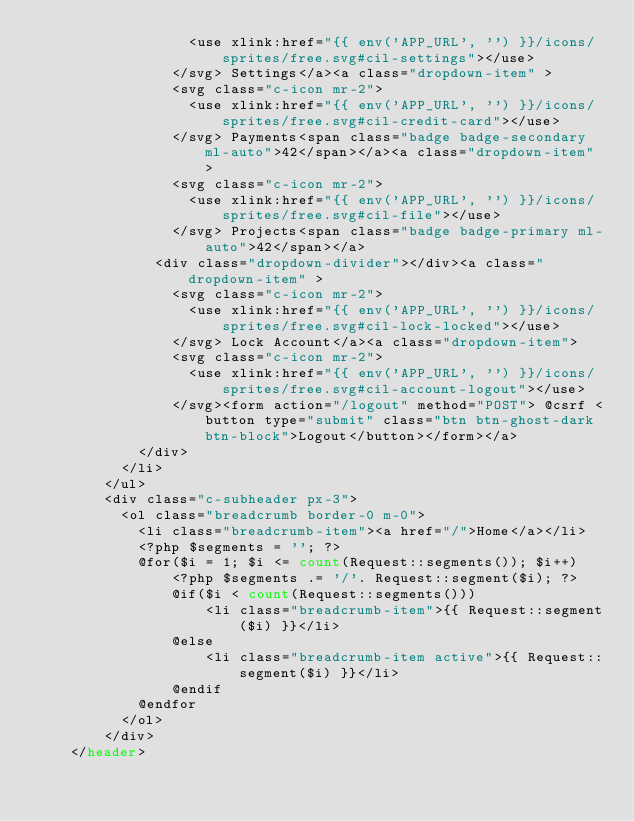Convert code to text. <code><loc_0><loc_0><loc_500><loc_500><_PHP_>                  <use xlink:href="{{ env('APP_URL', '') }}/icons/sprites/free.svg#cil-settings"></use>
                </svg> Settings</a><a class="dropdown-item" >
                <svg class="c-icon mr-2">
                  <use xlink:href="{{ env('APP_URL', '') }}/icons/sprites/free.svg#cil-credit-card"></use>
                </svg> Payments<span class="badge badge-secondary ml-auto">42</span></a><a class="dropdown-item" >
                <svg class="c-icon mr-2">
                  <use xlink:href="{{ env('APP_URL', '') }}/icons/sprites/free.svg#cil-file"></use>
                </svg> Projects<span class="badge badge-primary ml-auto">42</span></a>
              <div class="dropdown-divider"></div><a class="dropdown-item" >
                <svg class="c-icon mr-2">
                  <use xlink:href="{{ env('APP_URL', '') }}/icons/sprites/free.svg#cil-lock-locked"></use>
                </svg> Lock Account</a><a class="dropdown-item">
                <svg class="c-icon mr-2">
                  <use xlink:href="{{ env('APP_URL', '') }}/icons/sprites/free.svg#cil-account-logout"></use>
                </svg><form action="/logout" method="POST"> @csrf <button type="submit" class="btn btn-ghost-dark btn-block">Logout</button></form></a>
            </div>
          </li>
        </ul>
        <div class="c-subheader px-3">
          <ol class="breadcrumb border-0 m-0">
            <li class="breadcrumb-item"><a href="/">Home</a></li>
            <?php $segments = ''; ?>
            @for($i = 1; $i <= count(Request::segments()); $i++)
                <?php $segments .= '/'. Request::segment($i); ?>
                @if($i < count(Request::segments()))
                    <li class="breadcrumb-item">{{ Request::segment($i) }}</li>
                @else
                    <li class="breadcrumb-item active">{{ Request::segment($i) }}</li>
                @endif
            @endfor
          </ol>
        </div>
    </header></code> 